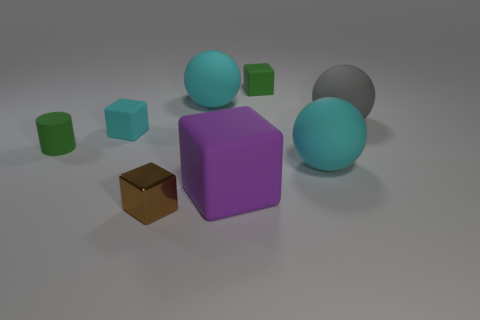There is a matte thing that is the same color as the small matte cylinder; what size is it?
Provide a succinct answer. Small. The rubber thing that is the same color as the cylinder is what shape?
Make the answer very short. Cube. There is a green matte object behind the gray matte sphere that is on the right side of the tiny rubber cylinder; what size is it?
Your response must be concise. Small. Do the brown cube and the green rubber cylinder have the same size?
Your answer should be very brief. Yes. There is a small green object in front of the small cube that is right of the shiny object; is there a green rubber cylinder behind it?
Offer a terse response. No. What is the size of the cyan rubber cube?
Offer a terse response. Small. How many cyan balls are the same size as the brown metallic thing?
Give a very brief answer. 0. There is a small cyan thing that is the same shape as the big purple rubber object; what is its material?
Keep it short and to the point. Rubber. What is the shape of the tiny rubber object that is both left of the big purple object and on the right side of the matte cylinder?
Keep it short and to the point. Cube. What shape is the small green rubber thing that is left of the tiny green cube?
Make the answer very short. Cylinder. 